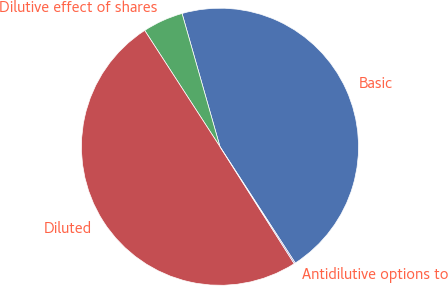Convert chart. <chart><loc_0><loc_0><loc_500><loc_500><pie_chart><fcel>Basic<fcel>Dilutive effect of shares<fcel>Diluted<fcel>Antidilutive options to<nl><fcel>45.27%<fcel>4.73%<fcel>49.86%<fcel>0.14%<nl></chart> 